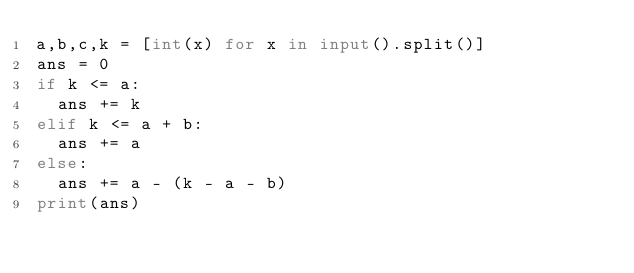<code> <loc_0><loc_0><loc_500><loc_500><_Python_>a,b,c,k = [int(x) for x in input().split()]
ans = 0
if k <= a:
  ans += k
elif k <= a + b:
  ans += a
else:
  ans += a - (k - a - b)
print(ans)</code> 